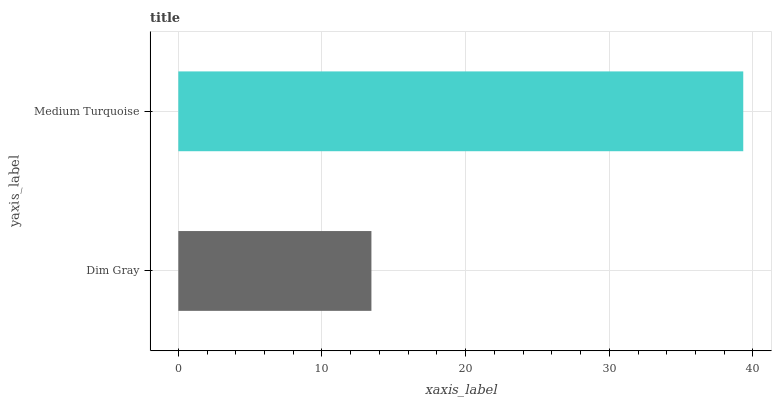Is Dim Gray the minimum?
Answer yes or no. Yes. Is Medium Turquoise the maximum?
Answer yes or no. Yes. Is Medium Turquoise the minimum?
Answer yes or no. No. Is Medium Turquoise greater than Dim Gray?
Answer yes or no. Yes. Is Dim Gray less than Medium Turquoise?
Answer yes or no. Yes. Is Dim Gray greater than Medium Turquoise?
Answer yes or no. No. Is Medium Turquoise less than Dim Gray?
Answer yes or no. No. Is Medium Turquoise the high median?
Answer yes or no. Yes. Is Dim Gray the low median?
Answer yes or no. Yes. Is Dim Gray the high median?
Answer yes or no. No. Is Medium Turquoise the low median?
Answer yes or no. No. 